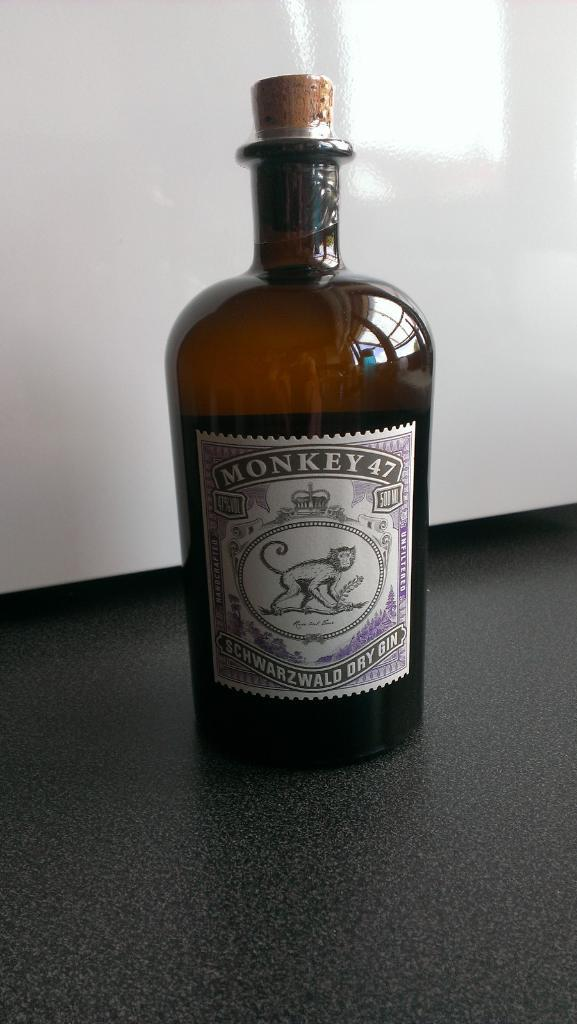<image>
Create a compact narrative representing the image presented. A bottle of Monkey 47 Schwarzwald Dry Gin. 